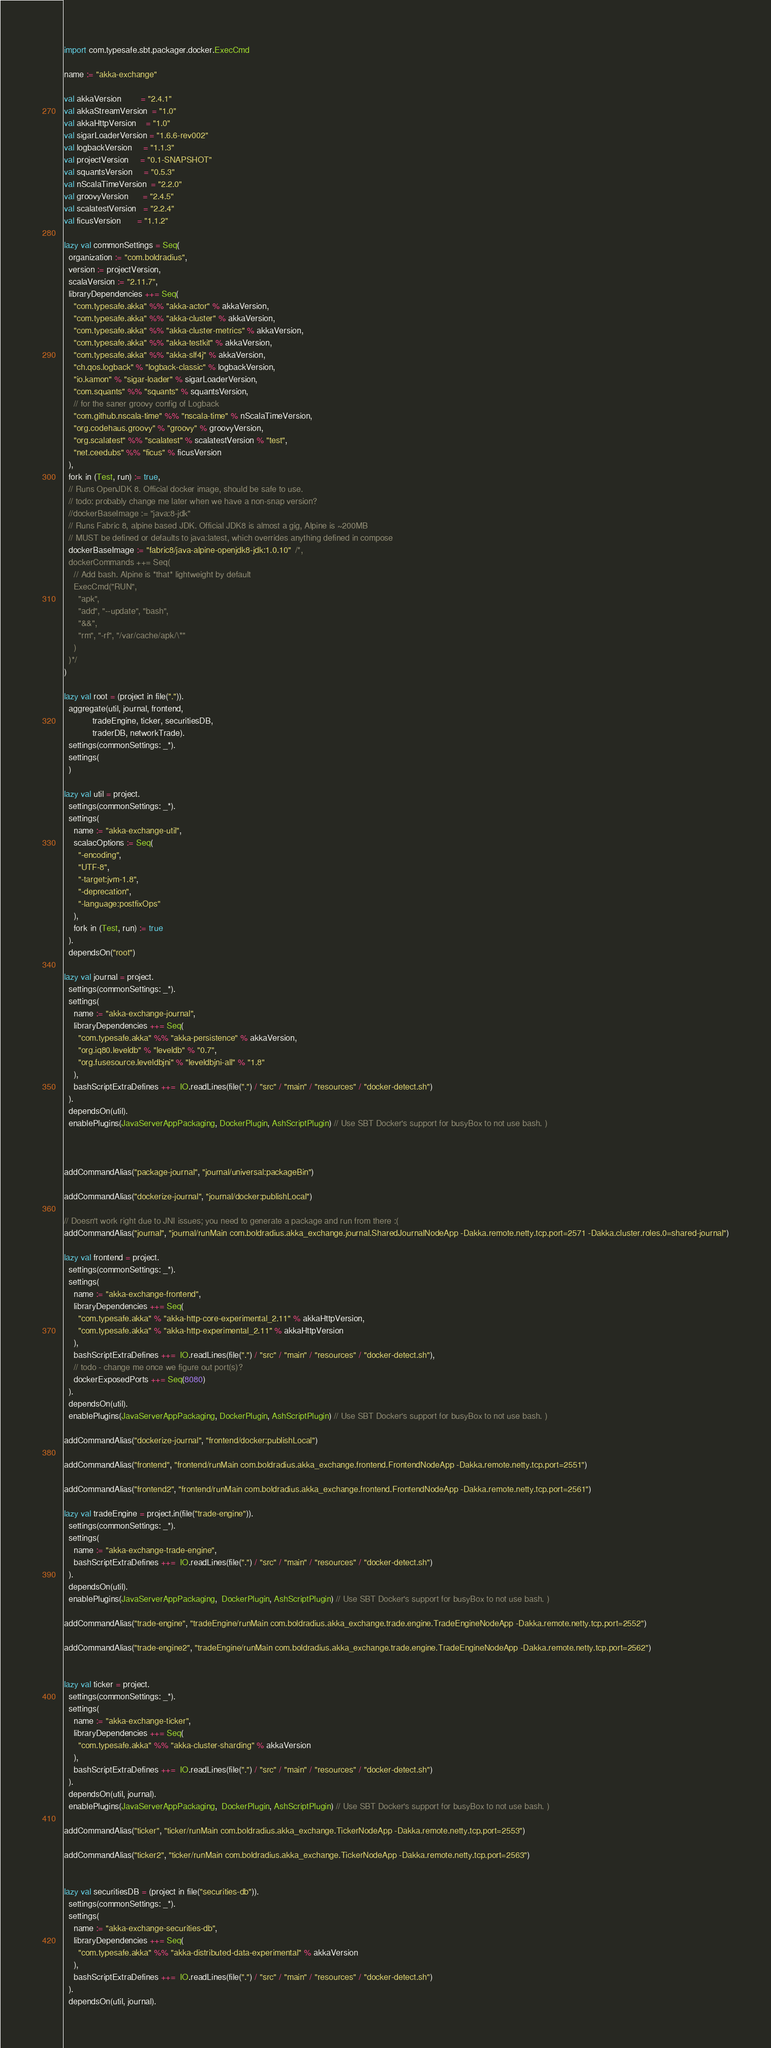Convert code to text. <code><loc_0><loc_0><loc_500><loc_500><_Scala_>import com.typesafe.sbt.packager.docker.ExecCmd

name := "akka-exchange"

val akkaVersion        = "2.4.1"
val akkaStreamVersion  = "1.0"
val akkaHttpVersion    = "1.0"
val sigarLoaderVersion = "1.6.6-rev002"
val logbackVersion     = "1.1.3"
val projectVersion     = "0.1-SNAPSHOT"
val squantsVersion     = "0.5.3"
val nScalaTimeVersion  = "2.2.0"
val groovyVersion      = "2.4.5"
val scalatestVersion   = "2.2.4"
val ficusVersion       = "1.1.2"

lazy val commonSettings = Seq(
  organization := "com.boldradius",
  version := projectVersion,
  scalaVersion := "2.11.7",
  libraryDependencies ++= Seq(
    "com.typesafe.akka" %% "akka-actor" % akkaVersion,
    "com.typesafe.akka" %% "akka-cluster" % akkaVersion,
    "com.typesafe.akka" %% "akka-cluster-metrics" % akkaVersion,
    "com.typesafe.akka" %% "akka-testkit" % akkaVersion,
    "com.typesafe.akka" %% "akka-slf4j" % akkaVersion,
    "ch.qos.logback" % "logback-classic" % logbackVersion,
    "io.kamon" % "sigar-loader" % sigarLoaderVersion,
    "com.squants" %% "squants" % squantsVersion,
    // for the saner groovy config of Logback
    "com.github.nscala-time" %% "nscala-time" % nScalaTimeVersion,
    "org.codehaus.groovy" % "groovy" % groovyVersion,
    "org.scalatest" %% "scalatest" % scalatestVersion % "test",
    "net.ceedubs" %% "ficus" % ficusVersion
  ),
  fork in (Test, run) := true,
  // Runs OpenJDK 8. Official docker image, should be safe to use.
  // todo: probably change me later when we have a non-snap version?
  //dockerBaseImage := "java:8-jdk"
  // Runs Fabric 8, alpine based JDK. Official JDK8 is almost a gig, Alpine is ~200MB
  // MUST be defined or defaults to java:latest, which overrides anything defined in compose
  dockerBaseImage := "fabric8/java-alpine-openjdk8-jdk:1.0.10"  /*,
  dockerCommands ++= Seq(
    // Add bash. Alpine is *that* lightweight by default
    ExecCmd("RUN",
      "apk",
      "add", "--update", "bash",
      "&&",
      "rm", "-rf", "/var/cache/apk/\*"
    )
  )*/
)

lazy val root = (project in file(".")).
  aggregate(util, journal, frontend,
            tradeEngine, ticker, securitiesDB,
            traderDB, networkTrade).
  settings(commonSettings: _*).
  settings(
  )

lazy val util = project.
  settings(commonSettings: _*).
  settings(
    name := "akka-exchange-util",
    scalacOptions := Seq(
      "-encoding",
      "UTF-8",
      "-target:jvm-1.8",
      "-deprecation",
      "-language:postfixOps"
    ),
    fork in (Test, run) := true
  ).
  dependsOn("root")

lazy val journal = project.
  settings(commonSettings: _*).
  settings(
    name := "akka-exchange-journal",
    libraryDependencies ++= Seq(
      "com.typesafe.akka" %% "akka-persistence" % akkaVersion,
      "org.iq80.leveldb" % "leveldb" % "0.7",
      "org.fusesource.leveldbjni" % "leveldbjni-all" % "1.8"
    ),
    bashScriptExtraDefines ++=  IO.readLines(file(".") / "src" / "main" / "resources" / "docker-detect.sh")
  ).
  dependsOn(util).
  enablePlugins(JavaServerAppPackaging, DockerPlugin, AshScriptPlugin) // Use SBT Docker's support for busyBox to not use bash. )



addCommandAlias("package-journal", "journal/universal:packageBin")

addCommandAlias("dockerize-journal", "journal/docker:publishLocal")

// Doesn't work right due to JNI issues; you need to generate a package and run from there :(
addCommandAlias("journal", "journal/runMain com.boldradius.akka_exchange.journal.SharedJournalNodeApp -Dakka.remote.netty.tcp.port=2571 -Dakka.cluster.roles.0=shared-journal")

lazy val frontend = project.
  settings(commonSettings: _*).
  settings(
    name := "akka-exchange-frontend",
    libraryDependencies ++= Seq(
      "com.typesafe.akka" % "akka-http-core-experimental_2.11" % akkaHttpVersion,
      "com.typesafe.akka" % "akka-http-experimental_2.11" % akkaHttpVersion
    ),
    bashScriptExtraDefines ++=  IO.readLines(file(".") / "src" / "main" / "resources" / "docker-detect.sh"),
    // todo - change me once we figure out port(s)?
    dockerExposedPorts ++= Seq(8080)
  ).
  dependsOn(util).
  enablePlugins(JavaServerAppPackaging, DockerPlugin, AshScriptPlugin) // Use SBT Docker's support for busyBox to not use bash. )

addCommandAlias("dockerize-journal", "frontend/docker:publishLocal")

addCommandAlias("frontend", "frontend/runMain com.boldradius.akka_exchange.frontend.FrontendNodeApp -Dakka.remote.netty.tcp.port=2551")

addCommandAlias("frontend2", "frontend/runMain com.boldradius.akka_exchange.frontend.FrontendNodeApp -Dakka.remote.netty.tcp.port=2561")

lazy val tradeEngine = project.in(file("trade-engine")).
  settings(commonSettings: _*).
  settings(
    name := "akka-exchange-trade-engine",
    bashScriptExtraDefines ++=  IO.readLines(file(".") / "src" / "main" / "resources" / "docker-detect.sh")
  ).
  dependsOn(util).
  enablePlugins(JavaServerAppPackaging,  DockerPlugin, AshScriptPlugin) // Use SBT Docker's support for busyBox to not use bash. )

addCommandAlias("trade-engine", "tradeEngine/runMain com.boldradius.akka_exchange.trade.engine.TradeEngineNodeApp -Dakka.remote.netty.tcp.port=2552")

addCommandAlias("trade-engine2", "tradeEngine/runMain com.boldradius.akka_exchange.trade.engine.TradeEngineNodeApp -Dakka.remote.netty.tcp.port=2562")


lazy val ticker = project.
  settings(commonSettings: _*).
  settings(
    name := "akka-exchange-ticker",
    libraryDependencies ++= Seq(
      "com.typesafe.akka" %% "akka-cluster-sharding" % akkaVersion
    ),
    bashScriptExtraDefines ++=  IO.readLines(file(".") / "src" / "main" / "resources" / "docker-detect.sh")
  ).
  dependsOn(util, journal).
  enablePlugins(JavaServerAppPackaging,  DockerPlugin, AshScriptPlugin) // Use SBT Docker's support for busyBox to not use bash. )

addCommandAlias("ticker", "ticker/runMain com.boldradius.akka_exchange.TickerNodeApp -Dakka.remote.netty.tcp.port=2553")

addCommandAlias("ticker2", "ticker/runMain com.boldradius.akka_exchange.TickerNodeApp -Dakka.remote.netty.tcp.port=2563")


lazy val securitiesDB = (project in file("securities-db")).
  settings(commonSettings: _*).
  settings(
    name := "akka-exchange-securities-db",
    libraryDependencies ++= Seq(
      "com.typesafe.akka" %% "akka-distributed-data-experimental" % akkaVersion
    ),
    bashScriptExtraDefines ++=  IO.readLines(file(".") / "src" / "main" / "resources" / "docker-detect.sh")
  ).
  dependsOn(util, journal).</code> 